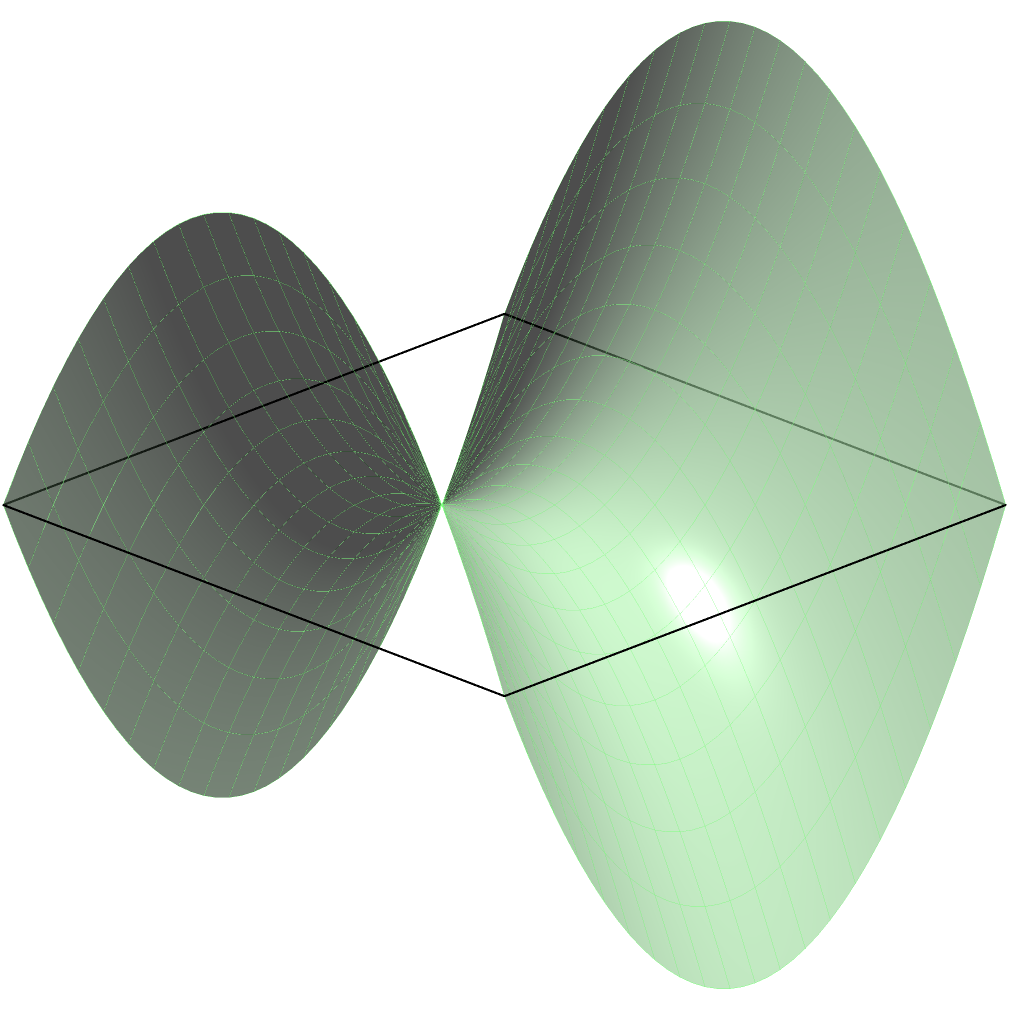As a council member overseeing local construction projects, you're tasked with optimizing transportation routes on a uniquely shaped construction site. The site's terrain resembles a saddle-shaped surface, as shown in the diagram. What is the most efficient path between points A and B, and why doesn't it follow a straight line when viewed from above? To understand the most efficient path between points A and B on this saddle-shaped surface, we need to consider the principles of non-Euclidean geometry:

1. The surface is described by the equation $z = x^2 - y^2$, which creates a saddle shape.

2. In Euclidean geometry (flat surface), the shortest path between two points is a straight line. However, on curved surfaces, this is not always true.

3. On a curved surface, the shortest path between two points is called a geodesic. Geodesics follow the curvature of the surface.

4. For a saddle-shaped surface:
   a. The path of the geodesic tends to curve away from the center along the direction of negative curvature (the "valleys").
   b. It curves towards the center along the direction of positive curvature (the "hills").

5. In this case, the geodesic (shown in red) curves slightly outward from the straight line connecting A and B when viewed from above.

6. This curvature allows the path to minimize the total distance traveled across the surface's ups and downs, making it more efficient than a straight line when considering the actual 3D distance.

7. The exact shape of the geodesic can be calculated using differential geometry, specifically the geodesic equation, which takes into account the surface's metric tensor.

In the context of construction, understanding this principle could help in designing more efficient transportation routes or utility lines across uneven terrains, potentially saving time and resources.
Answer: The most efficient path is a curved geodesic that follows the surface's curvature, not a straight line. 